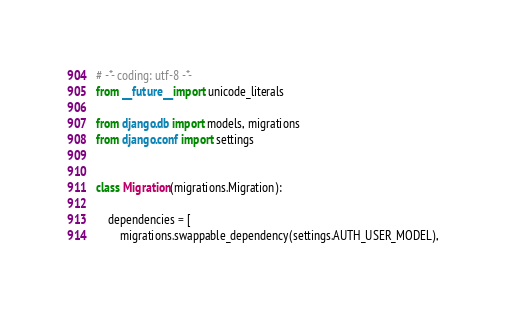<code> <loc_0><loc_0><loc_500><loc_500><_Python_># -*- coding: utf-8 -*-
from __future__ import unicode_literals

from django.db import models, migrations
from django.conf import settings


class Migration(migrations.Migration):

    dependencies = [
        migrations.swappable_dependency(settings.AUTH_USER_MODEL),</code> 